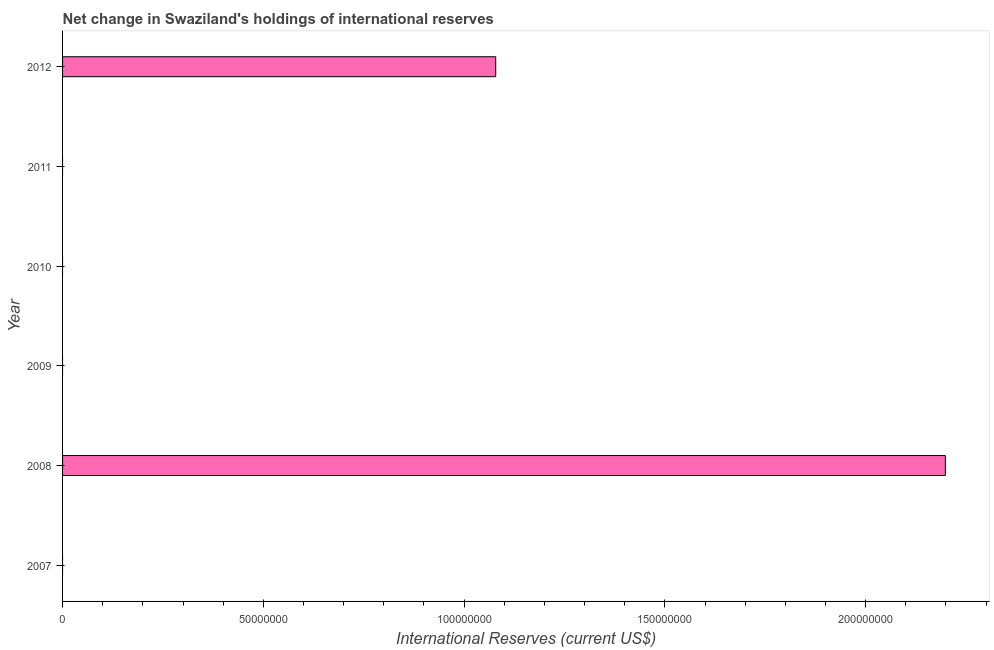Does the graph contain any zero values?
Your response must be concise. Yes. Does the graph contain grids?
Provide a succinct answer. No. What is the title of the graph?
Your answer should be very brief. Net change in Swaziland's holdings of international reserves. What is the label or title of the X-axis?
Your answer should be very brief. International Reserves (current US$). What is the reserves and related items in 2009?
Ensure brevity in your answer.  0. Across all years, what is the maximum reserves and related items?
Your answer should be very brief. 2.20e+08. What is the sum of the reserves and related items?
Provide a succinct answer. 3.28e+08. What is the difference between the reserves and related items in 2008 and 2012?
Provide a short and direct response. 1.12e+08. What is the average reserves and related items per year?
Your answer should be compact. 5.46e+07. In how many years, is the reserves and related items greater than 90000000 US$?
Ensure brevity in your answer.  2. What is the ratio of the reserves and related items in 2008 to that in 2012?
Provide a succinct answer. 2.04. What is the difference between the highest and the lowest reserves and related items?
Keep it short and to the point. 2.20e+08. In how many years, is the reserves and related items greater than the average reserves and related items taken over all years?
Ensure brevity in your answer.  2. How many bars are there?
Offer a very short reply. 2. What is the difference between two consecutive major ticks on the X-axis?
Your answer should be compact. 5.00e+07. What is the International Reserves (current US$) in 2008?
Offer a very short reply. 2.20e+08. What is the International Reserves (current US$) of 2009?
Make the answer very short. 0. What is the International Reserves (current US$) in 2010?
Your answer should be very brief. 0. What is the International Reserves (current US$) in 2012?
Ensure brevity in your answer.  1.08e+08. What is the difference between the International Reserves (current US$) in 2008 and 2012?
Offer a very short reply. 1.12e+08. What is the ratio of the International Reserves (current US$) in 2008 to that in 2012?
Your answer should be compact. 2.04. 